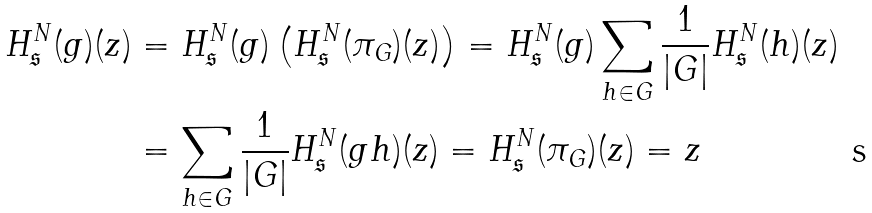Convert formula to latex. <formula><loc_0><loc_0><loc_500><loc_500>H _ { \mathfrak { s } } ^ { N } ( g ) ( z ) & = H _ { \mathfrak { s } } ^ { N } ( g ) \left ( H _ { \mathfrak { s } } ^ { N } ( \pi _ { G } ) ( z ) \right ) = H _ { \mathfrak { s } } ^ { N } ( g ) \sum _ { h \in G } { \frac { 1 } { | G | } H _ { \mathfrak { s } } ^ { N } ( h ) ( z ) } \\ & = \sum _ { h \in G } { \frac { 1 } { | G | } H _ { \mathfrak { s } } ^ { N } ( g h ) ( z ) } = H _ { \mathfrak { s } } ^ { N } ( \pi _ { G } ) ( z ) = z</formula> 